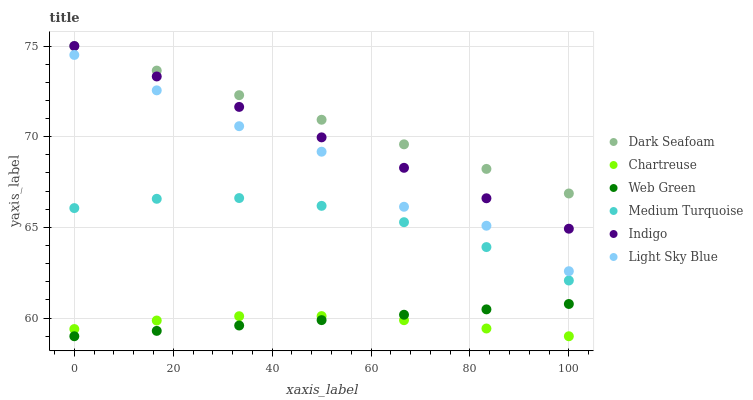Does Chartreuse have the minimum area under the curve?
Answer yes or no. Yes. Does Dark Seafoam have the maximum area under the curve?
Answer yes or no. Yes. Does Web Green have the minimum area under the curve?
Answer yes or no. No. Does Web Green have the maximum area under the curve?
Answer yes or no. No. Is Web Green the smoothest?
Answer yes or no. Yes. Is Light Sky Blue the roughest?
Answer yes or no. Yes. Is Chartreuse the smoothest?
Answer yes or no. No. Is Chartreuse the roughest?
Answer yes or no. No. Does Chartreuse have the lowest value?
Answer yes or no. Yes. Does Dark Seafoam have the lowest value?
Answer yes or no. No. Does Dark Seafoam have the highest value?
Answer yes or no. Yes. Does Web Green have the highest value?
Answer yes or no. No. Is Chartreuse less than Dark Seafoam?
Answer yes or no. Yes. Is Light Sky Blue greater than Medium Turquoise?
Answer yes or no. Yes. Does Chartreuse intersect Web Green?
Answer yes or no. Yes. Is Chartreuse less than Web Green?
Answer yes or no. No. Is Chartreuse greater than Web Green?
Answer yes or no. No. Does Chartreuse intersect Dark Seafoam?
Answer yes or no. No. 